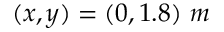Convert formula to latex. <formula><loc_0><loc_0><loc_500><loc_500>( x , y ) = ( 0 , 1 . 8 ) \ m</formula> 